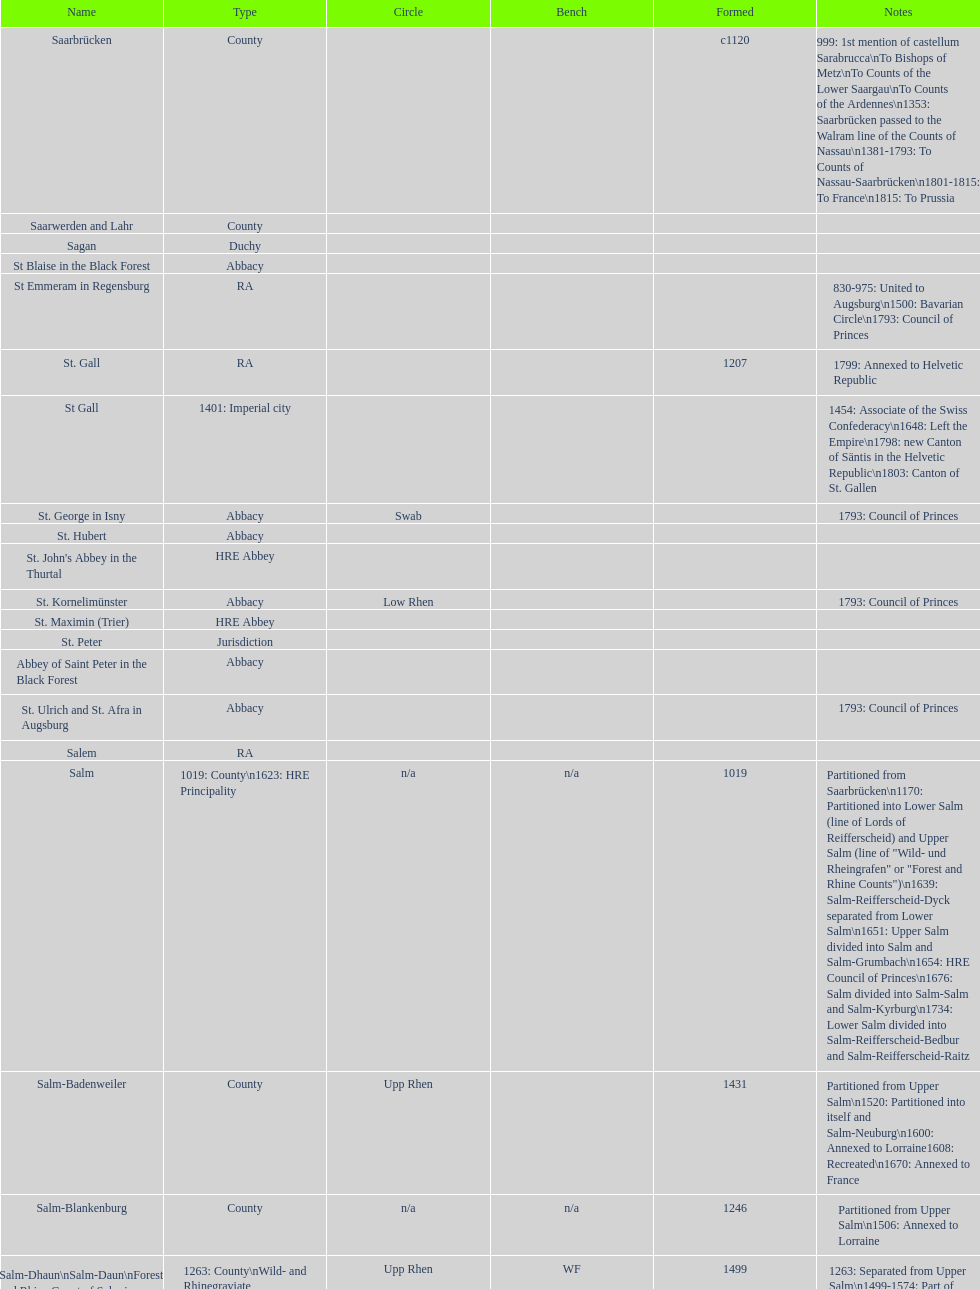Which bench is represented the most? PR. 